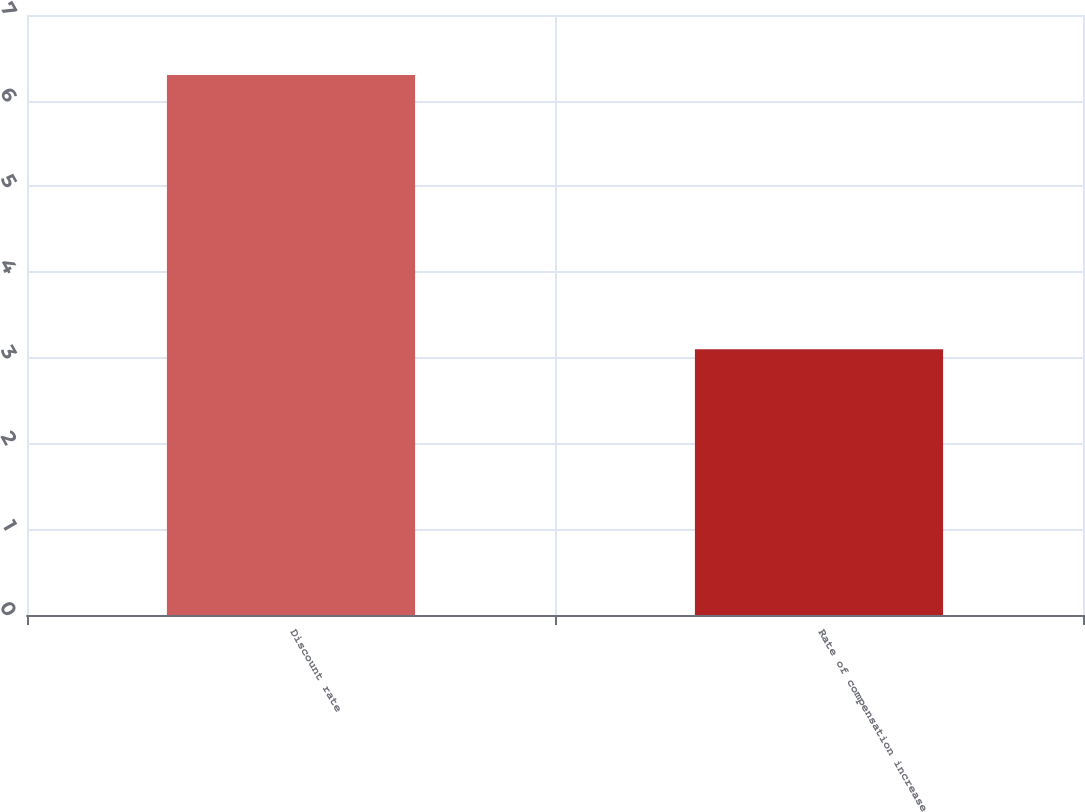Convert chart to OTSL. <chart><loc_0><loc_0><loc_500><loc_500><bar_chart><fcel>Discount rate<fcel>Rate of compensation increase<nl><fcel>6.3<fcel>3.1<nl></chart> 